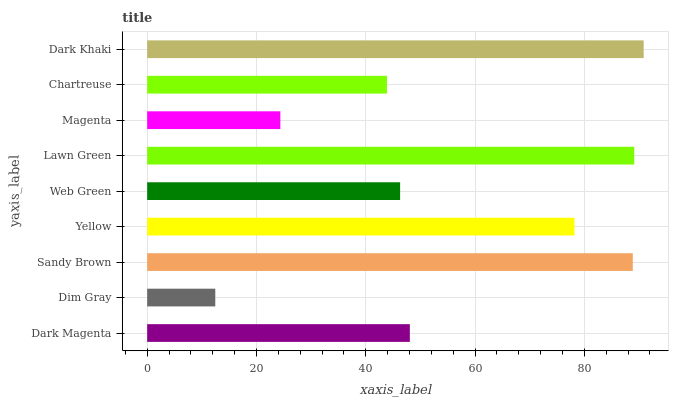Is Dim Gray the minimum?
Answer yes or no. Yes. Is Dark Khaki the maximum?
Answer yes or no. Yes. Is Sandy Brown the minimum?
Answer yes or no. No. Is Sandy Brown the maximum?
Answer yes or no. No. Is Sandy Brown greater than Dim Gray?
Answer yes or no. Yes. Is Dim Gray less than Sandy Brown?
Answer yes or no. Yes. Is Dim Gray greater than Sandy Brown?
Answer yes or no. No. Is Sandy Brown less than Dim Gray?
Answer yes or no. No. Is Dark Magenta the high median?
Answer yes or no. Yes. Is Dark Magenta the low median?
Answer yes or no. Yes. Is Dark Khaki the high median?
Answer yes or no. No. Is Web Green the low median?
Answer yes or no. No. 